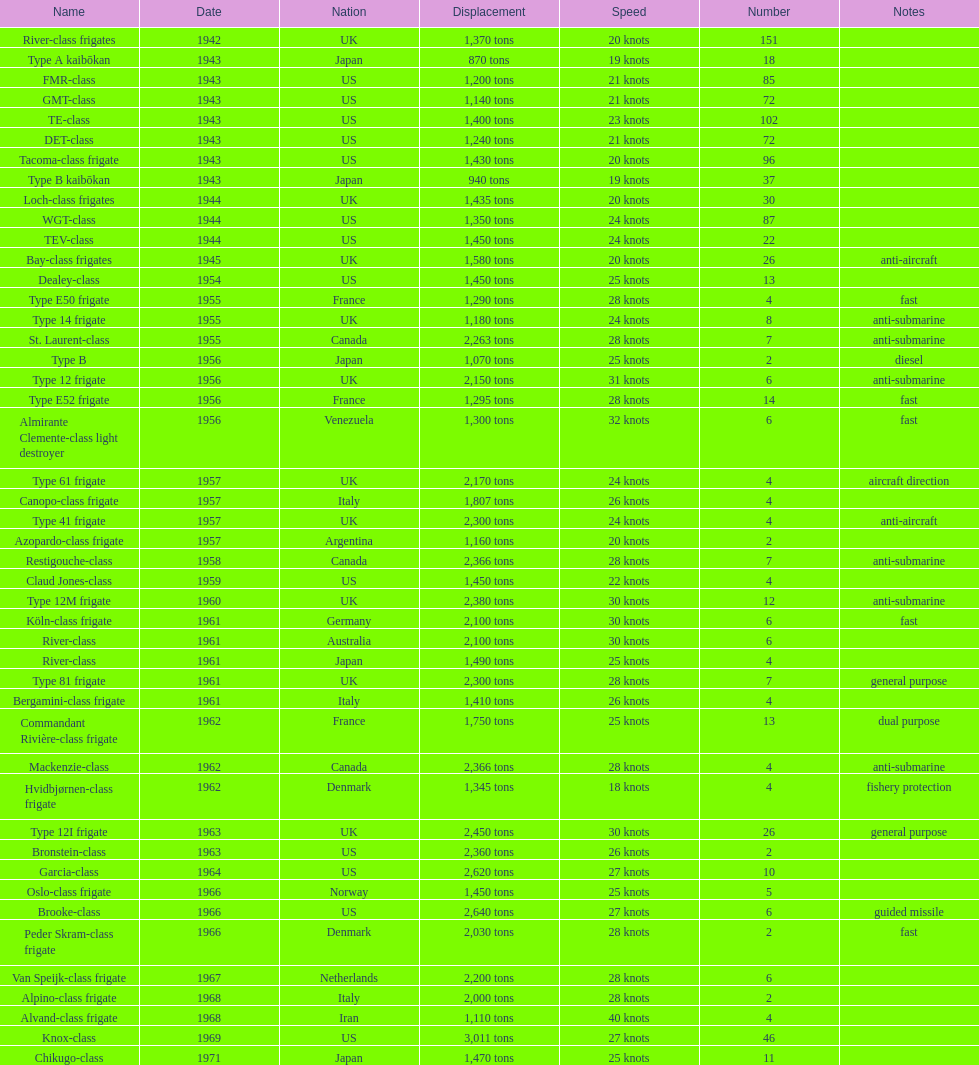What's the tonnage of displacement for type b? 940 tons. 